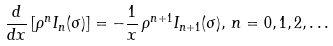<formula> <loc_0><loc_0><loc_500><loc_500>\frac { d } { d x } \left [ \rho ^ { n } I _ { n } ( \sigma ) \right ] = - \frac { 1 } { x } \, \rho ^ { n + 1 } I _ { n + 1 } ( \sigma ) , \, n = 0 , 1 , 2 , \dots</formula> 